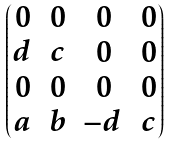<formula> <loc_0><loc_0><loc_500><loc_500>\begin{pmatrix} 0 & 0 & 0 & 0 \\ d & c & 0 & 0 \\ 0 & 0 & 0 & 0 \\ a & b & - d & c \end{pmatrix}</formula> 